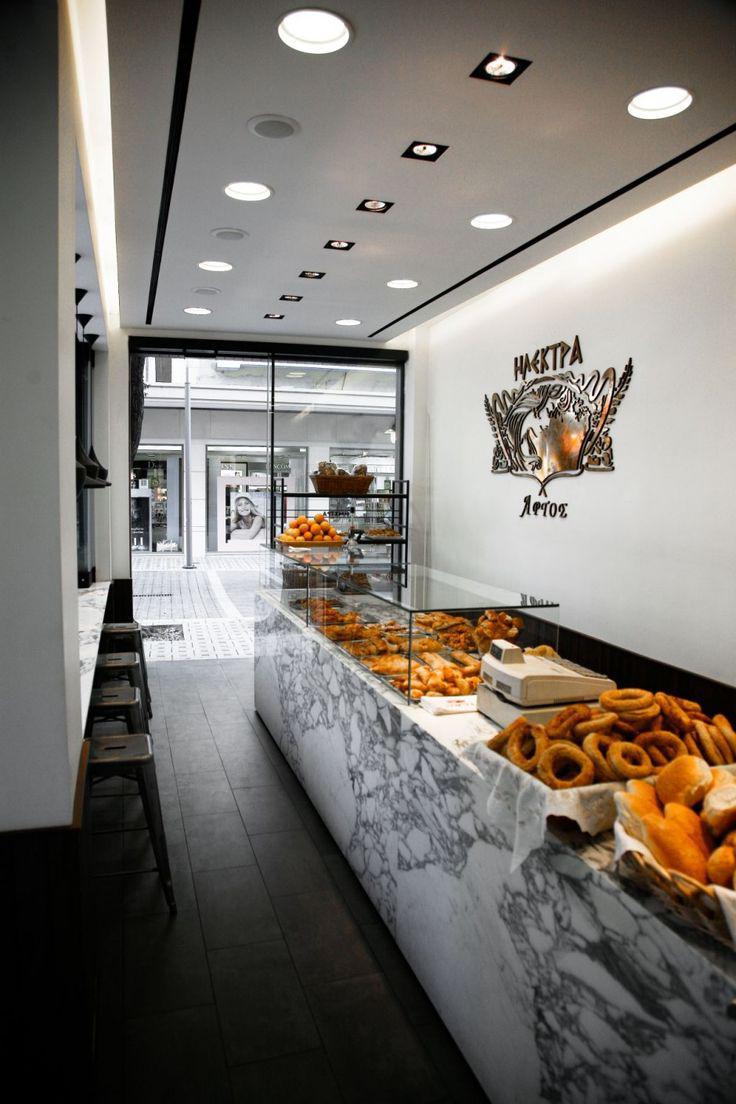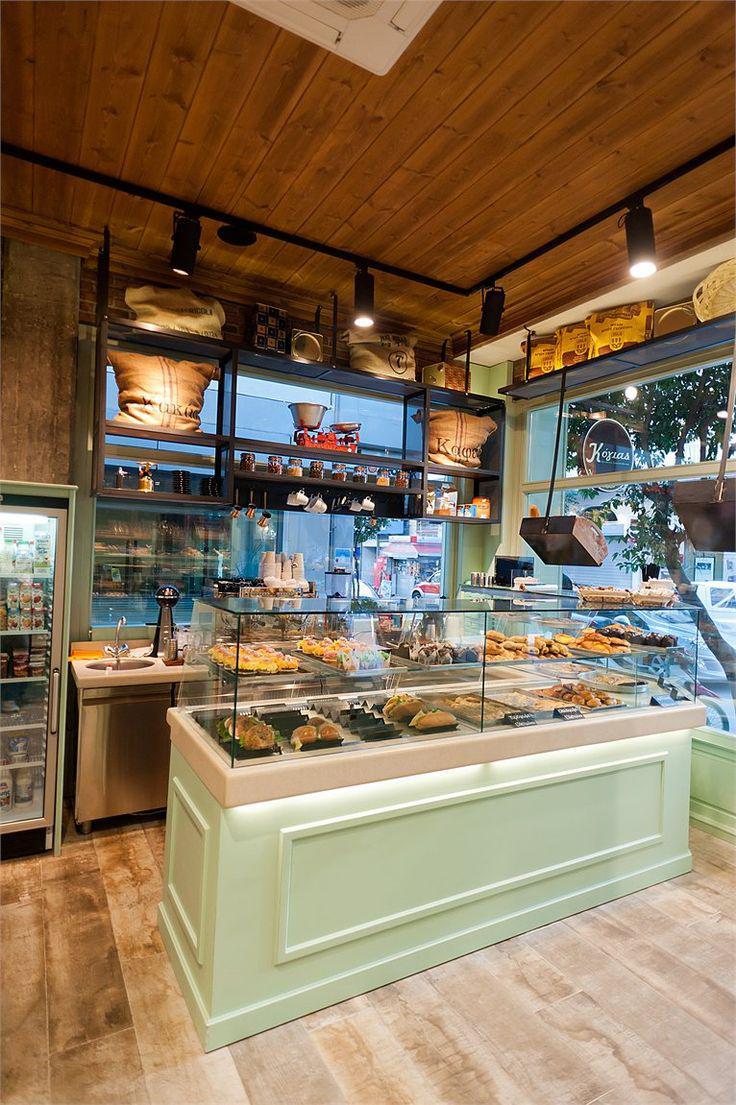The first image is the image on the left, the second image is the image on the right. Evaluate the accuracy of this statement regarding the images: "One of the places has a wooden floor.". Is it true? Answer yes or no. Yes. 